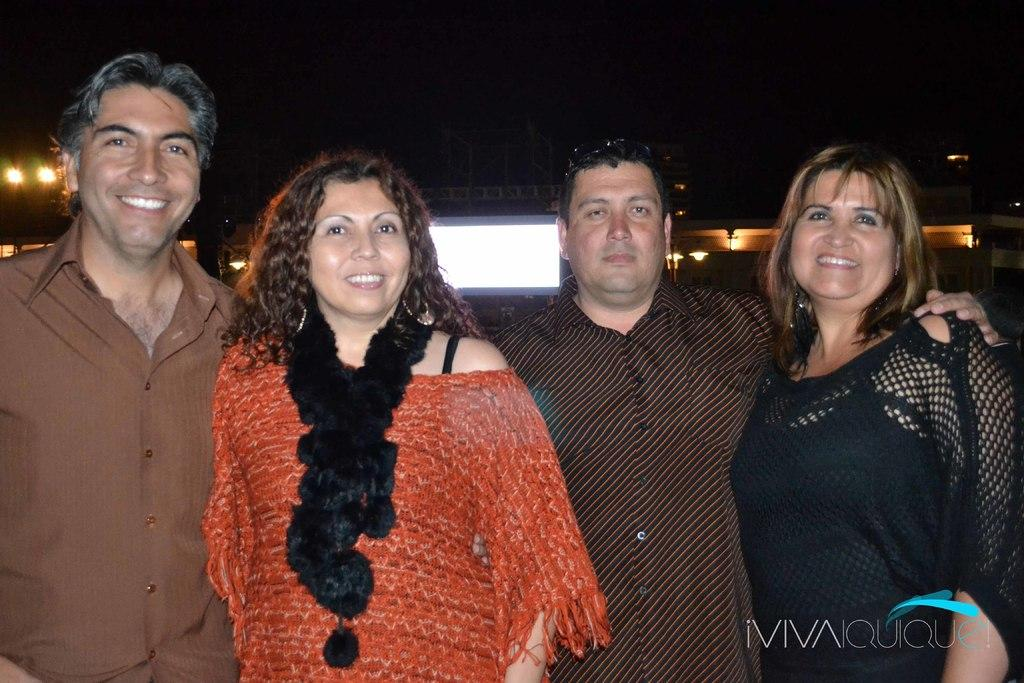What colors are the dresses of the persons in the image? The persons are wearing brown, orange, and black colored dresses in the image. What are the persons doing in the image? The persons are standing in the image. What can be seen in the background of the image? There are lights, buildings, and a dark sky in the background of the image. What type of pencil can be seen in the image? There is no pencil present in the image. Is there a plane visible in the image? No, there is no plane visible in the image. 